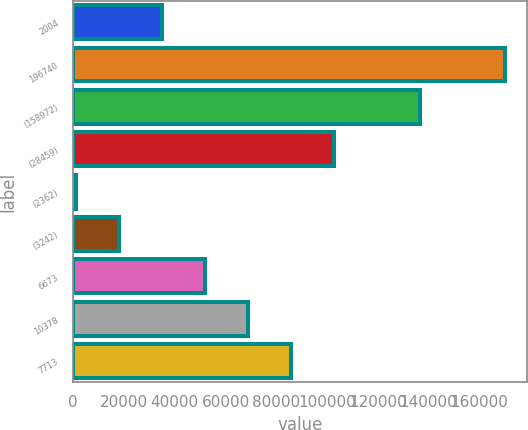<chart> <loc_0><loc_0><loc_500><loc_500><bar_chart><fcel>2004<fcel>196740<fcel>(158972)<fcel>(28459)<fcel>(2362)<fcel>(3242)<fcel>6673<fcel>10378<fcel>7713<nl><fcel>35044.6<fcel>170195<fcel>136745<fcel>102620<fcel>1257<fcel>18150.8<fcel>51938.4<fcel>68832.2<fcel>85726<nl></chart> 